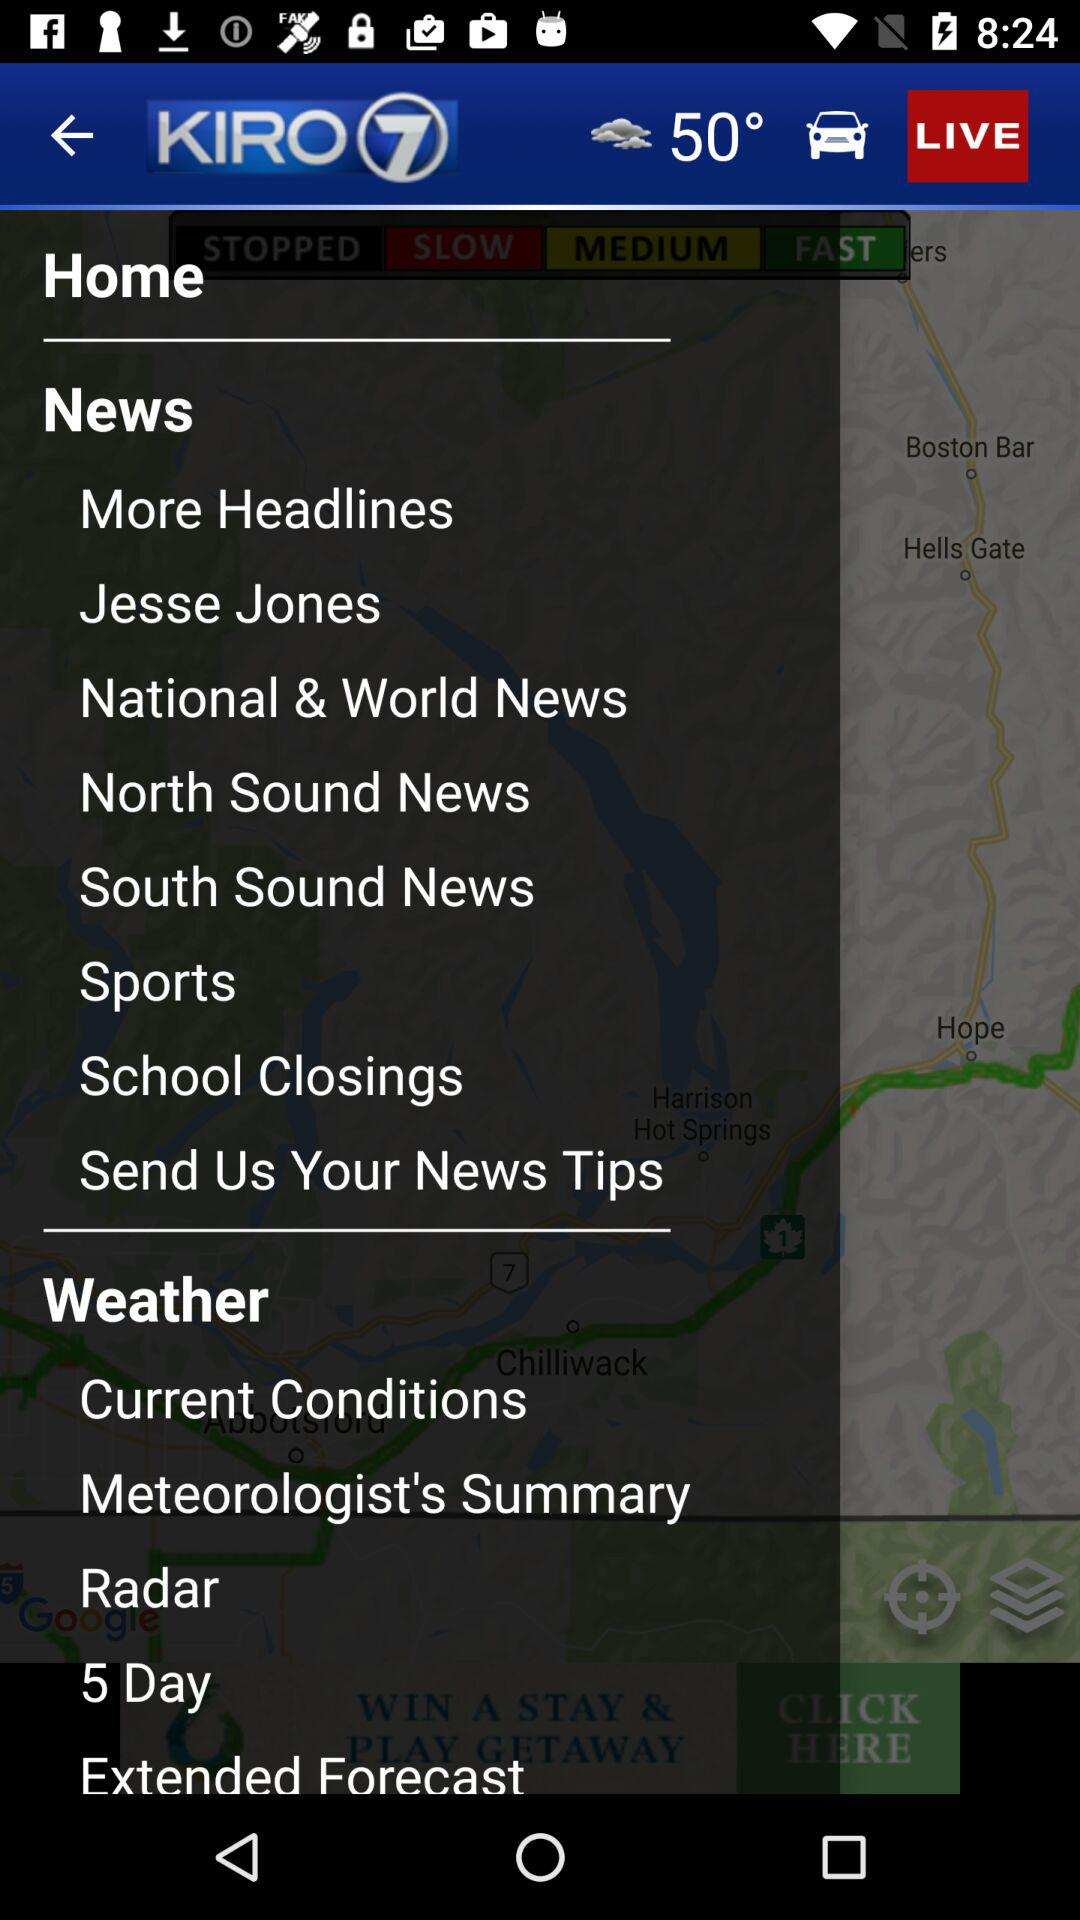What is the name of the application? The name of the application is "KIRO 7". 